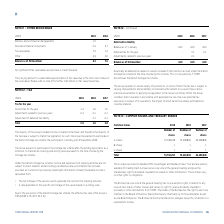According to Torm's financial document, Why is the carrying amount a reasonable approximation of fair value? due to the short-term nature of the receivables. The document states: "mount is a reasonable approximation of fair value due to the short-term nature of the receivables. Please refer to note 21 for further information on ..." Also, What information does note 21 contain? further information on fair value hierarchies. The document states: "e of the receivables. Please refer to note 21 for further information on fair value hierarchies. NOTE 12 – TAX..." Also, What are the components under Other Receivables in the table? The document contains multiple relevant values: Partners and commercial managements, Derivative financial instruments, Tax receivables, Other. From the document: "Derivative financial instruments 0.5 3.7 Partners and commercial managements 1.9 - Tax receivables 1.5 1.2 Other 2.3 2.6..." Additionally, In which year was the amount of Other larger? According to the financial document, 2018. The relevant text states: "USDm 2019 2018..." Also, can you calculate: What was the change in the Balance as of 31 December from 2018 to 2019? Based on the calculation: 6.2-7.5, the result is -1.3 (in millions). This is based on the information: "Balance as of 31 December 6.2 7.5 Balance as of 31 December 6.2 7.5..." The key data points involved are: 6.2, 7.5. Also, can you calculate: What was the percentage change in the Balance as of 31 December from 2018 to 2019? To answer this question, I need to perform calculations using the financial data. The calculation is: (6.2-7.5)/7.5, which equals -17.33 (percentage). This is based on the information: "Balance as of 31 December 6.2 7.5 Balance as of 31 December 6.2 7.5..." The key data points involved are: 6.2, 7.5. 